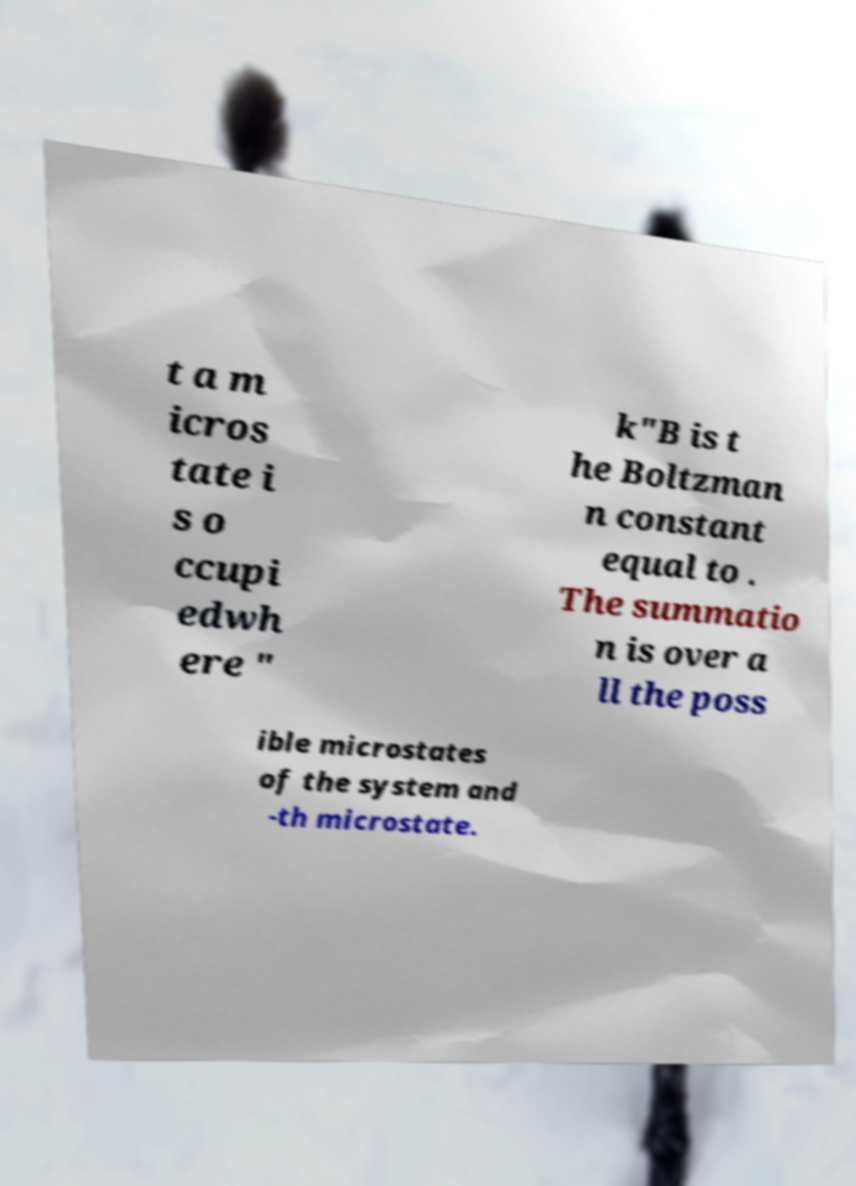Could you extract and type out the text from this image? t a m icros tate i s o ccupi edwh ere " k"B is t he Boltzman n constant equal to . The summatio n is over a ll the poss ible microstates of the system and -th microstate. 